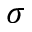Convert formula to latex. <formula><loc_0><loc_0><loc_500><loc_500>\sigma</formula> 